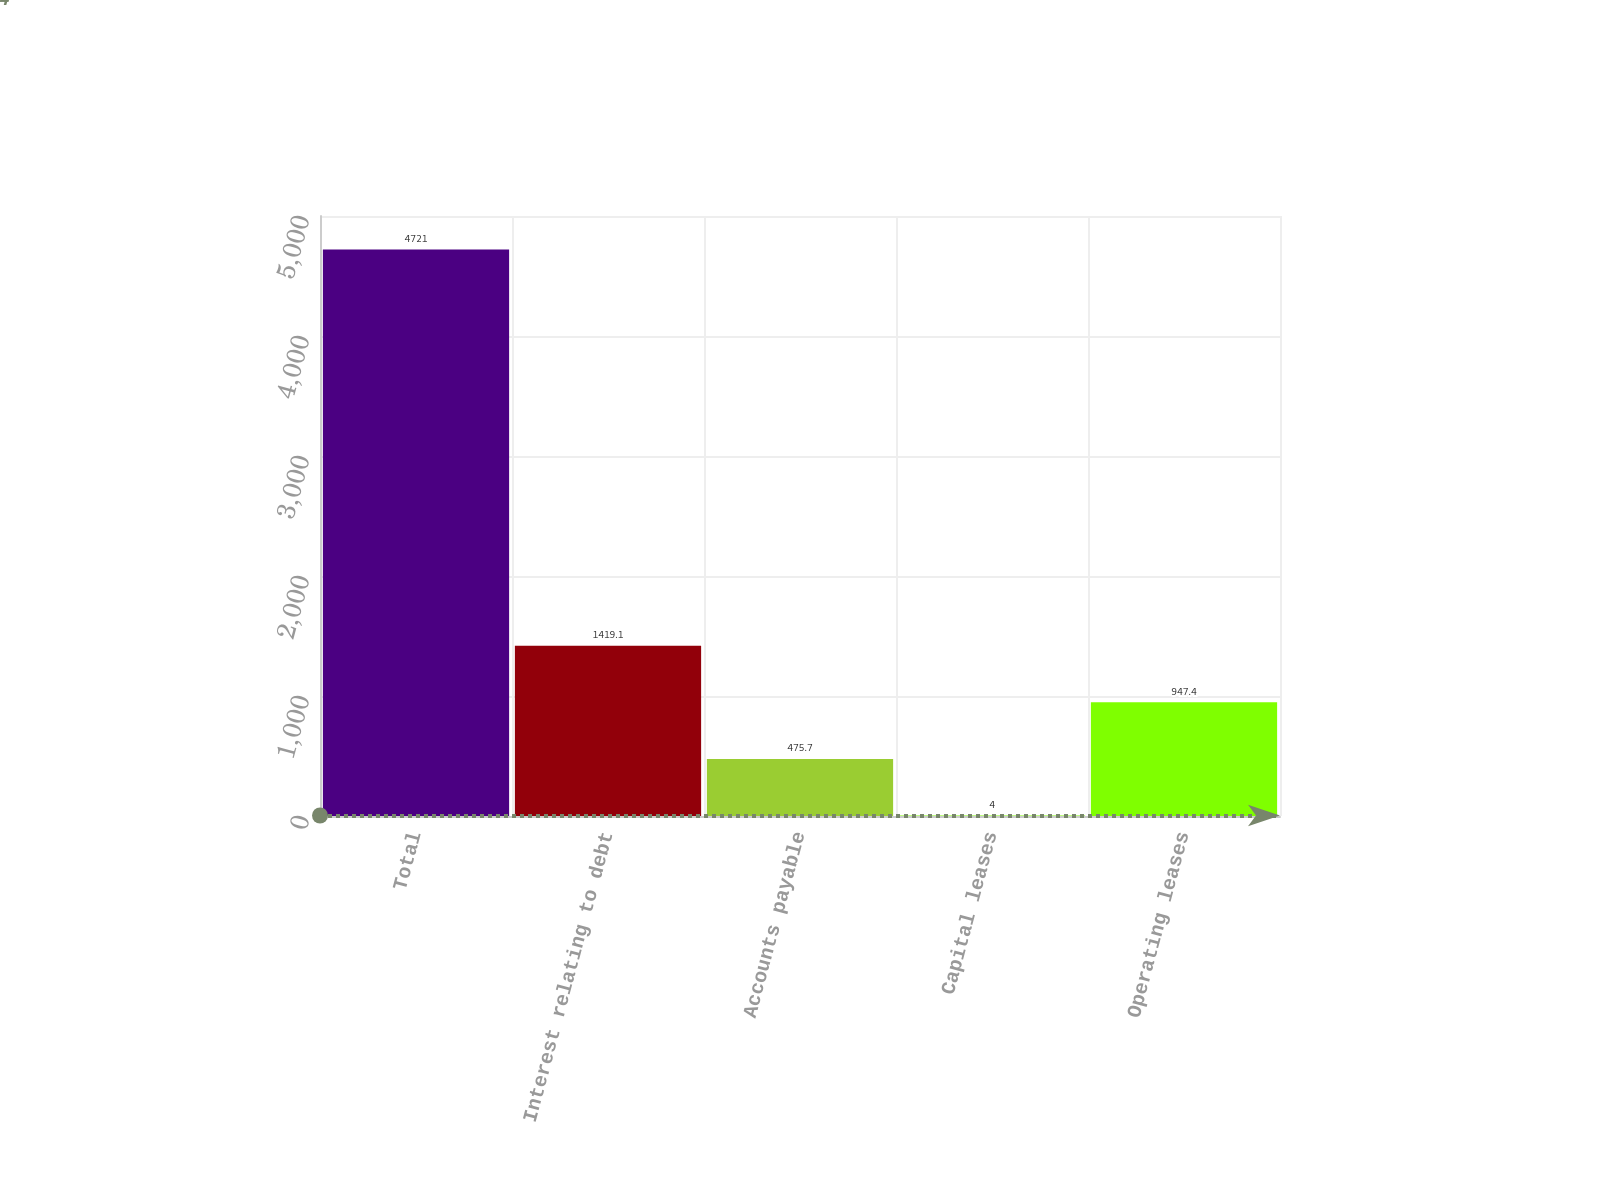Convert chart. <chart><loc_0><loc_0><loc_500><loc_500><bar_chart><fcel>Total<fcel>Interest relating to debt<fcel>Accounts payable<fcel>Capital leases<fcel>Operating leases<nl><fcel>4721<fcel>1419.1<fcel>475.7<fcel>4<fcel>947.4<nl></chart> 